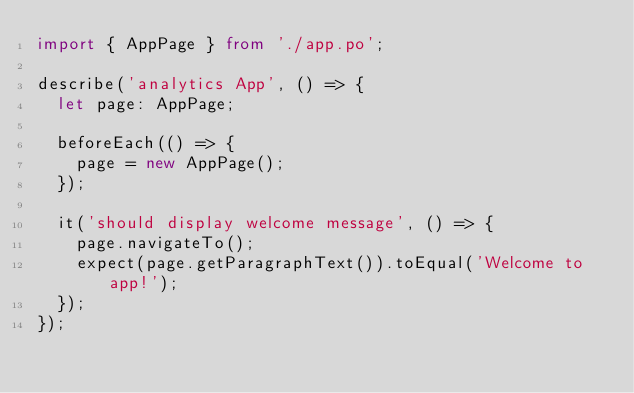Convert code to text. <code><loc_0><loc_0><loc_500><loc_500><_TypeScript_>import { AppPage } from './app.po';

describe('analytics App', () => {
  let page: AppPage;

  beforeEach(() => {
    page = new AppPage();
  });

  it('should display welcome message', () => {
    page.navigateTo();
    expect(page.getParagraphText()).toEqual('Welcome to app!');
  });
});
</code> 